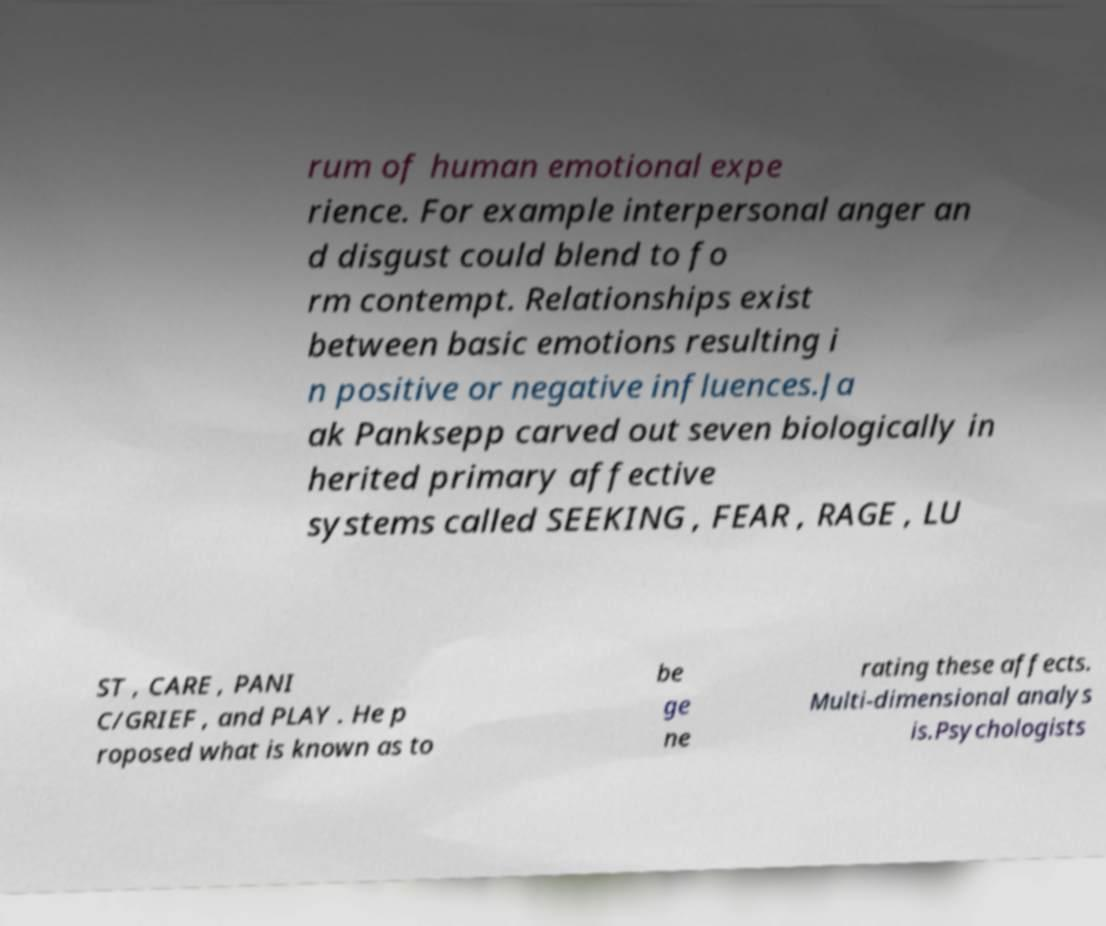Could you assist in decoding the text presented in this image and type it out clearly? rum of human emotional expe rience. For example interpersonal anger an d disgust could blend to fo rm contempt. Relationships exist between basic emotions resulting i n positive or negative influences.Ja ak Panksepp carved out seven biologically in herited primary affective systems called SEEKING , FEAR , RAGE , LU ST , CARE , PANI C/GRIEF , and PLAY . He p roposed what is known as to be ge ne rating these affects. Multi-dimensional analys is.Psychologists 